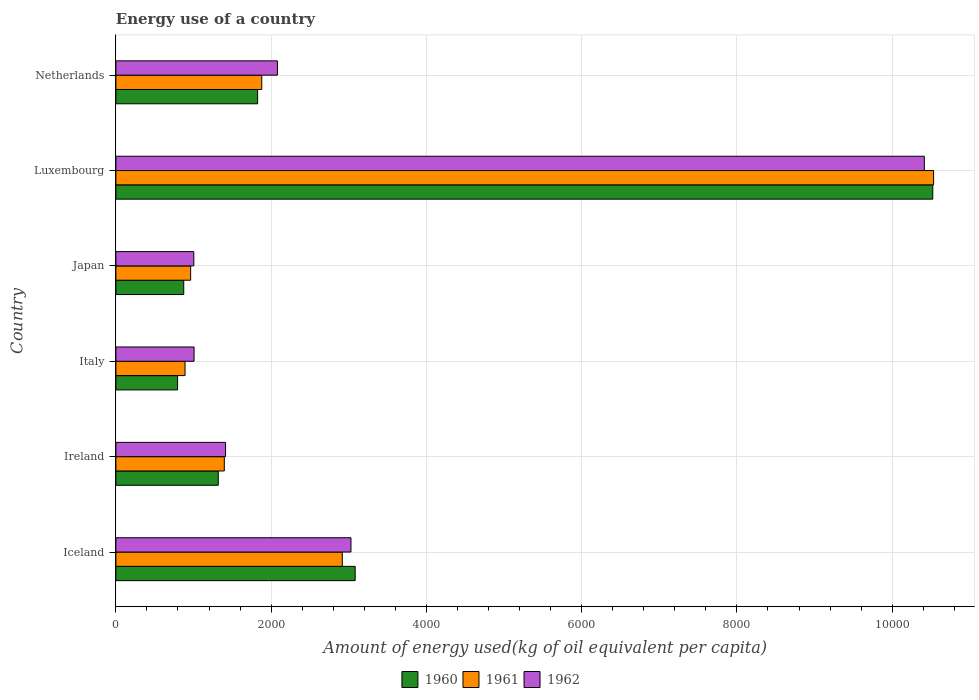How many groups of bars are there?
Provide a succinct answer. 6. Are the number of bars per tick equal to the number of legend labels?
Provide a succinct answer. Yes. How many bars are there on the 1st tick from the top?
Provide a short and direct response. 3. How many bars are there on the 2nd tick from the bottom?
Ensure brevity in your answer.  3. In how many cases, is the number of bars for a given country not equal to the number of legend labels?
Ensure brevity in your answer.  0. What is the amount of energy used in in 1961 in Ireland?
Provide a short and direct response. 1396.47. Across all countries, what is the maximum amount of energy used in in 1962?
Provide a short and direct response. 1.04e+04. Across all countries, what is the minimum amount of energy used in in 1960?
Your answer should be very brief. 794.82. In which country was the amount of energy used in in 1961 maximum?
Offer a very short reply. Luxembourg. What is the total amount of energy used in in 1960 in the graph?
Offer a terse response. 1.84e+04. What is the difference between the amount of energy used in in 1962 in Iceland and that in Italy?
Offer a very short reply. 2021.25. What is the difference between the amount of energy used in in 1961 in Japan and the amount of energy used in in 1962 in Ireland?
Ensure brevity in your answer.  -449.82. What is the average amount of energy used in in 1962 per country?
Offer a terse response. 3157.9. What is the difference between the amount of energy used in in 1962 and amount of energy used in in 1961 in Netherlands?
Give a very brief answer. 201.86. In how many countries, is the amount of energy used in in 1960 greater than 6000 kg?
Provide a short and direct response. 1. What is the ratio of the amount of energy used in in 1962 in Ireland to that in Netherlands?
Give a very brief answer. 0.68. Is the amount of energy used in in 1960 in Iceland less than that in Italy?
Your answer should be compact. No. What is the difference between the highest and the second highest amount of energy used in in 1961?
Your answer should be very brief. 7617.31. What is the difference between the highest and the lowest amount of energy used in in 1961?
Provide a succinct answer. 9643.33. In how many countries, is the amount of energy used in in 1960 greater than the average amount of energy used in in 1960 taken over all countries?
Give a very brief answer. 2. Is the sum of the amount of energy used in in 1960 in Ireland and Luxembourg greater than the maximum amount of energy used in in 1962 across all countries?
Make the answer very short. Yes. What does the 3rd bar from the top in Ireland represents?
Give a very brief answer. 1960. Is it the case that in every country, the sum of the amount of energy used in in 1962 and amount of energy used in in 1961 is greater than the amount of energy used in in 1960?
Provide a succinct answer. Yes. How many countries are there in the graph?
Provide a short and direct response. 6. How many legend labels are there?
Offer a very short reply. 3. What is the title of the graph?
Provide a succinct answer. Energy use of a country. What is the label or title of the X-axis?
Offer a very short reply. Amount of energy used(kg of oil equivalent per capita). What is the Amount of energy used(kg of oil equivalent per capita) of 1960 in Iceland?
Make the answer very short. 3082.71. What is the Amount of energy used(kg of oil equivalent per capita) of 1961 in Iceland?
Provide a short and direct response. 2916.71. What is the Amount of energy used(kg of oil equivalent per capita) in 1962 in Iceland?
Your response must be concise. 3028.3. What is the Amount of energy used(kg of oil equivalent per capita) in 1960 in Ireland?
Keep it short and to the point. 1318.81. What is the Amount of energy used(kg of oil equivalent per capita) in 1961 in Ireland?
Provide a succinct answer. 1396.47. What is the Amount of energy used(kg of oil equivalent per capita) of 1962 in Ireland?
Keep it short and to the point. 1412.73. What is the Amount of energy used(kg of oil equivalent per capita) of 1960 in Italy?
Your answer should be compact. 794.82. What is the Amount of energy used(kg of oil equivalent per capita) in 1961 in Italy?
Make the answer very short. 890.69. What is the Amount of energy used(kg of oil equivalent per capita) in 1962 in Italy?
Offer a very short reply. 1007.05. What is the Amount of energy used(kg of oil equivalent per capita) in 1960 in Japan?
Provide a succinct answer. 873.91. What is the Amount of energy used(kg of oil equivalent per capita) of 1961 in Japan?
Give a very brief answer. 962.91. What is the Amount of energy used(kg of oil equivalent per capita) of 1962 in Japan?
Keep it short and to the point. 1003.75. What is the Amount of energy used(kg of oil equivalent per capita) of 1960 in Luxembourg?
Ensure brevity in your answer.  1.05e+04. What is the Amount of energy used(kg of oil equivalent per capita) of 1961 in Luxembourg?
Provide a short and direct response. 1.05e+04. What is the Amount of energy used(kg of oil equivalent per capita) in 1962 in Luxembourg?
Make the answer very short. 1.04e+04. What is the Amount of energy used(kg of oil equivalent per capita) of 1960 in Netherlands?
Give a very brief answer. 1825.93. What is the Amount of energy used(kg of oil equivalent per capita) in 1961 in Netherlands?
Give a very brief answer. 1879.15. What is the Amount of energy used(kg of oil equivalent per capita) of 1962 in Netherlands?
Your answer should be compact. 2081.01. Across all countries, what is the maximum Amount of energy used(kg of oil equivalent per capita) of 1960?
Offer a very short reply. 1.05e+04. Across all countries, what is the maximum Amount of energy used(kg of oil equivalent per capita) in 1961?
Give a very brief answer. 1.05e+04. Across all countries, what is the maximum Amount of energy used(kg of oil equivalent per capita) of 1962?
Ensure brevity in your answer.  1.04e+04. Across all countries, what is the minimum Amount of energy used(kg of oil equivalent per capita) of 1960?
Provide a short and direct response. 794.82. Across all countries, what is the minimum Amount of energy used(kg of oil equivalent per capita) in 1961?
Your answer should be very brief. 890.69. Across all countries, what is the minimum Amount of energy used(kg of oil equivalent per capita) of 1962?
Give a very brief answer. 1003.75. What is the total Amount of energy used(kg of oil equivalent per capita) in 1960 in the graph?
Your answer should be compact. 1.84e+04. What is the total Amount of energy used(kg of oil equivalent per capita) in 1961 in the graph?
Give a very brief answer. 1.86e+04. What is the total Amount of energy used(kg of oil equivalent per capita) of 1962 in the graph?
Your answer should be very brief. 1.89e+04. What is the difference between the Amount of energy used(kg of oil equivalent per capita) in 1960 in Iceland and that in Ireland?
Make the answer very short. 1763.9. What is the difference between the Amount of energy used(kg of oil equivalent per capita) in 1961 in Iceland and that in Ireland?
Your answer should be very brief. 1520.24. What is the difference between the Amount of energy used(kg of oil equivalent per capita) of 1962 in Iceland and that in Ireland?
Your response must be concise. 1615.57. What is the difference between the Amount of energy used(kg of oil equivalent per capita) in 1960 in Iceland and that in Italy?
Your answer should be very brief. 2287.9. What is the difference between the Amount of energy used(kg of oil equivalent per capita) of 1961 in Iceland and that in Italy?
Offer a very short reply. 2026.02. What is the difference between the Amount of energy used(kg of oil equivalent per capita) of 1962 in Iceland and that in Italy?
Your answer should be very brief. 2021.25. What is the difference between the Amount of energy used(kg of oil equivalent per capita) in 1960 in Iceland and that in Japan?
Offer a very short reply. 2208.8. What is the difference between the Amount of energy used(kg of oil equivalent per capita) in 1961 in Iceland and that in Japan?
Your answer should be very brief. 1953.8. What is the difference between the Amount of energy used(kg of oil equivalent per capita) in 1962 in Iceland and that in Japan?
Ensure brevity in your answer.  2024.55. What is the difference between the Amount of energy used(kg of oil equivalent per capita) in 1960 in Iceland and that in Luxembourg?
Offer a very short reply. -7440.7. What is the difference between the Amount of energy used(kg of oil equivalent per capita) in 1961 in Iceland and that in Luxembourg?
Offer a terse response. -7617.31. What is the difference between the Amount of energy used(kg of oil equivalent per capita) in 1962 in Iceland and that in Luxembourg?
Provide a short and direct response. -7386.24. What is the difference between the Amount of energy used(kg of oil equivalent per capita) in 1960 in Iceland and that in Netherlands?
Offer a terse response. 1256.78. What is the difference between the Amount of energy used(kg of oil equivalent per capita) in 1961 in Iceland and that in Netherlands?
Your answer should be very brief. 1037.56. What is the difference between the Amount of energy used(kg of oil equivalent per capita) of 1962 in Iceland and that in Netherlands?
Keep it short and to the point. 947.29. What is the difference between the Amount of energy used(kg of oil equivalent per capita) in 1960 in Ireland and that in Italy?
Your answer should be compact. 524. What is the difference between the Amount of energy used(kg of oil equivalent per capita) of 1961 in Ireland and that in Italy?
Offer a terse response. 505.78. What is the difference between the Amount of energy used(kg of oil equivalent per capita) in 1962 in Ireland and that in Italy?
Give a very brief answer. 405.68. What is the difference between the Amount of energy used(kg of oil equivalent per capita) in 1960 in Ireland and that in Japan?
Your answer should be compact. 444.9. What is the difference between the Amount of energy used(kg of oil equivalent per capita) of 1961 in Ireland and that in Japan?
Your response must be concise. 433.56. What is the difference between the Amount of energy used(kg of oil equivalent per capita) of 1962 in Ireland and that in Japan?
Your answer should be compact. 408.98. What is the difference between the Amount of energy used(kg of oil equivalent per capita) of 1960 in Ireland and that in Luxembourg?
Your response must be concise. -9204.59. What is the difference between the Amount of energy used(kg of oil equivalent per capita) in 1961 in Ireland and that in Luxembourg?
Give a very brief answer. -9137.55. What is the difference between the Amount of energy used(kg of oil equivalent per capita) in 1962 in Ireland and that in Luxembourg?
Keep it short and to the point. -9001.81. What is the difference between the Amount of energy used(kg of oil equivalent per capita) of 1960 in Ireland and that in Netherlands?
Your answer should be very brief. -507.12. What is the difference between the Amount of energy used(kg of oil equivalent per capita) in 1961 in Ireland and that in Netherlands?
Give a very brief answer. -482.68. What is the difference between the Amount of energy used(kg of oil equivalent per capita) in 1962 in Ireland and that in Netherlands?
Your response must be concise. -668.28. What is the difference between the Amount of energy used(kg of oil equivalent per capita) in 1960 in Italy and that in Japan?
Provide a succinct answer. -79.09. What is the difference between the Amount of energy used(kg of oil equivalent per capita) in 1961 in Italy and that in Japan?
Your answer should be very brief. -72.22. What is the difference between the Amount of energy used(kg of oil equivalent per capita) of 1962 in Italy and that in Japan?
Your answer should be compact. 3.3. What is the difference between the Amount of energy used(kg of oil equivalent per capita) in 1960 in Italy and that in Luxembourg?
Your answer should be very brief. -9728.59. What is the difference between the Amount of energy used(kg of oil equivalent per capita) in 1961 in Italy and that in Luxembourg?
Provide a short and direct response. -9643.33. What is the difference between the Amount of energy used(kg of oil equivalent per capita) of 1962 in Italy and that in Luxembourg?
Provide a short and direct response. -9407.49. What is the difference between the Amount of energy used(kg of oil equivalent per capita) of 1960 in Italy and that in Netherlands?
Your response must be concise. -1031.12. What is the difference between the Amount of energy used(kg of oil equivalent per capita) of 1961 in Italy and that in Netherlands?
Give a very brief answer. -988.46. What is the difference between the Amount of energy used(kg of oil equivalent per capita) of 1962 in Italy and that in Netherlands?
Give a very brief answer. -1073.96. What is the difference between the Amount of energy used(kg of oil equivalent per capita) of 1960 in Japan and that in Luxembourg?
Make the answer very short. -9649.5. What is the difference between the Amount of energy used(kg of oil equivalent per capita) in 1961 in Japan and that in Luxembourg?
Offer a terse response. -9571.11. What is the difference between the Amount of energy used(kg of oil equivalent per capita) in 1962 in Japan and that in Luxembourg?
Keep it short and to the point. -9410.79. What is the difference between the Amount of energy used(kg of oil equivalent per capita) in 1960 in Japan and that in Netherlands?
Your answer should be very brief. -952.02. What is the difference between the Amount of energy used(kg of oil equivalent per capita) of 1961 in Japan and that in Netherlands?
Provide a short and direct response. -916.24. What is the difference between the Amount of energy used(kg of oil equivalent per capita) in 1962 in Japan and that in Netherlands?
Provide a short and direct response. -1077.26. What is the difference between the Amount of energy used(kg of oil equivalent per capita) of 1960 in Luxembourg and that in Netherlands?
Keep it short and to the point. 8697.47. What is the difference between the Amount of energy used(kg of oil equivalent per capita) of 1961 in Luxembourg and that in Netherlands?
Offer a very short reply. 8654.87. What is the difference between the Amount of energy used(kg of oil equivalent per capita) in 1962 in Luxembourg and that in Netherlands?
Offer a terse response. 8333.53. What is the difference between the Amount of energy used(kg of oil equivalent per capita) of 1960 in Iceland and the Amount of energy used(kg of oil equivalent per capita) of 1961 in Ireland?
Give a very brief answer. 1686.25. What is the difference between the Amount of energy used(kg of oil equivalent per capita) of 1960 in Iceland and the Amount of energy used(kg of oil equivalent per capita) of 1962 in Ireland?
Make the answer very short. 1669.98. What is the difference between the Amount of energy used(kg of oil equivalent per capita) in 1961 in Iceland and the Amount of energy used(kg of oil equivalent per capita) in 1962 in Ireland?
Provide a short and direct response. 1503.98. What is the difference between the Amount of energy used(kg of oil equivalent per capita) in 1960 in Iceland and the Amount of energy used(kg of oil equivalent per capita) in 1961 in Italy?
Offer a very short reply. 2192.02. What is the difference between the Amount of energy used(kg of oil equivalent per capita) in 1960 in Iceland and the Amount of energy used(kg of oil equivalent per capita) in 1962 in Italy?
Ensure brevity in your answer.  2075.66. What is the difference between the Amount of energy used(kg of oil equivalent per capita) in 1961 in Iceland and the Amount of energy used(kg of oil equivalent per capita) in 1962 in Italy?
Your answer should be compact. 1909.66. What is the difference between the Amount of energy used(kg of oil equivalent per capita) in 1960 in Iceland and the Amount of energy used(kg of oil equivalent per capita) in 1961 in Japan?
Ensure brevity in your answer.  2119.8. What is the difference between the Amount of energy used(kg of oil equivalent per capita) in 1960 in Iceland and the Amount of energy used(kg of oil equivalent per capita) in 1962 in Japan?
Your answer should be compact. 2078.96. What is the difference between the Amount of energy used(kg of oil equivalent per capita) in 1961 in Iceland and the Amount of energy used(kg of oil equivalent per capita) in 1962 in Japan?
Ensure brevity in your answer.  1912.95. What is the difference between the Amount of energy used(kg of oil equivalent per capita) in 1960 in Iceland and the Amount of energy used(kg of oil equivalent per capita) in 1961 in Luxembourg?
Offer a terse response. -7451.31. What is the difference between the Amount of energy used(kg of oil equivalent per capita) in 1960 in Iceland and the Amount of energy used(kg of oil equivalent per capita) in 1962 in Luxembourg?
Offer a terse response. -7331.83. What is the difference between the Amount of energy used(kg of oil equivalent per capita) in 1961 in Iceland and the Amount of energy used(kg of oil equivalent per capita) in 1962 in Luxembourg?
Your response must be concise. -7497.83. What is the difference between the Amount of energy used(kg of oil equivalent per capita) in 1960 in Iceland and the Amount of energy used(kg of oil equivalent per capita) in 1961 in Netherlands?
Your answer should be compact. 1203.56. What is the difference between the Amount of energy used(kg of oil equivalent per capita) in 1960 in Iceland and the Amount of energy used(kg of oil equivalent per capita) in 1962 in Netherlands?
Provide a short and direct response. 1001.7. What is the difference between the Amount of energy used(kg of oil equivalent per capita) of 1961 in Iceland and the Amount of energy used(kg of oil equivalent per capita) of 1962 in Netherlands?
Provide a short and direct response. 835.69. What is the difference between the Amount of energy used(kg of oil equivalent per capita) of 1960 in Ireland and the Amount of energy used(kg of oil equivalent per capita) of 1961 in Italy?
Your answer should be compact. 428.12. What is the difference between the Amount of energy used(kg of oil equivalent per capita) in 1960 in Ireland and the Amount of energy used(kg of oil equivalent per capita) in 1962 in Italy?
Provide a succinct answer. 311.76. What is the difference between the Amount of energy used(kg of oil equivalent per capita) of 1961 in Ireland and the Amount of energy used(kg of oil equivalent per capita) of 1962 in Italy?
Ensure brevity in your answer.  389.42. What is the difference between the Amount of energy used(kg of oil equivalent per capita) in 1960 in Ireland and the Amount of energy used(kg of oil equivalent per capita) in 1961 in Japan?
Offer a very short reply. 355.91. What is the difference between the Amount of energy used(kg of oil equivalent per capita) in 1960 in Ireland and the Amount of energy used(kg of oil equivalent per capita) in 1962 in Japan?
Offer a terse response. 315.06. What is the difference between the Amount of energy used(kg of oil equivalent per capita) in 1961 in Ireland and the Amount of energy used(kg of oil equivalent per capita) in 1962 in Japan?
Give a very brief answer. 392.71. What is the difference between the Amount of energy used(kg of oil equivalent per capita) of 1960 in Ireland and the Amount of energy used(kg of oil equivalent per capita) of 1961 in Luxembourg?
Make the answer very short. -9215.21. What is the difference between the Amount of energy used(kg of oil equivalent per capita) in 1960 in Ireland and the Amount of energy used(kg of oil equivalent per capita) in 1962 in Luxembourg?
Make the answer very short. -9095.73. What is the difference between the Amount of energy used(kg of oil equivalent per capita) in 1961 in Ireland and the Amount of energy used(kg of oil equivalent per capita) in 1962 in Luxembourg?
Ensure brevity in your answer.  -9018.07. What is the difference between the Amount of energy used(kg of oil equivalent per capita) of 1960 in Ireland and the Amount of energy used(kg of oil equivalent per capita) of 1961 in Netherlands?
Ensure brevity in your answer.  -560.34. What is the difference between the Amount of energy used(kg of oil equivalent per capita) in 1960 in Ireland and the Amount of energy used(kg of oil equivalent per capita) in 1962 in Netherlands?
Your answer should be compact. -762.2. What is the difference between the Amount of energy used(kg of oil equivalent per capita) in 1961 in Ireland and the Amount of energy used(kg of oil equivalent per capita) in 1962 in Netherlands?
Give a very brief answer. -684.55. What is the difference between the Amount of energy used(kg of oil equivalent per capita) in 1960 in Italy and the Amount of energy used(kg of oil equivalent per capita) in 1961 in Japan?
Give a very brief answer. -168.09. What is the difference between the Amount of energy used(kg of oil equivalent per capita) of 1960 in Italy and the Amount of energy used(kg of oil equivalent per capita) of 1962 in Japan?
Offer a very short reply. -208.94. What is the difference between the Amount of energy used(kg of oil equivalent per capita) in 1961 in Italy and the Amount of energy used(kg of oil equivalent per capita) in 1962 in Japan?
Provide a short and direct response. -113.06. What is the difference between the Amount of energy used(kg of oil equivalent per capita) of 1960 in Italy and the Amount of energy used(kg of oil equivalent per capita) of 1961 in Luxembourg?
Give a very brief answer. -9739.2. What is the difference between the Amount of energy used(kg of oil equivalent per capita) of 1960 in Italy and the Amount of energy used(kg of oil equivalent per capita) of 1962 in Luxembourg?
Offer a terse response. -9619.72. What is the difference between the Amount of energy used(kg of oil equivalent per capita) in 1961 in Italy and the Amount of energy used(kg of oil equivalent per capita) in 1962 in Luxembourg?
Give a very brief answer. -9523.85. What is the difference between the Amount of energy used(kg of oil equivalent per capita) in 1960 in Italy and the Amount of energy used(kg of oil equivalent per capita) in 1961 in Netherlands?
Make the answer very short. -1084.33. What is the difference between the Amount of energy used(kg of oil equivalent per capita) of 1960 in Italy and the Amount of energy used(kg of oil equivalent per capita) of 1962 in Netherlands?
Provide a succinct answer. -1286.2. What is the difference between the Amount of energy used(kg of oil equivalent per capita) of 1961 in Italy and the Amount of energy used(kg of oil equivalent per capita) of 1962 in Netherlands?
Keep it short and to the point. -1190.32. What is the difference between the Amount of energy used(kg of oil equivalent per capita) of 1960 in Japan and the Amount of energy used(kg of oil equivalent per capita) of 1961 in Luxembourg?
Provide a succinct answer. -9660.11. What is the difference between the Amount of energy used(kg of oil equivalent per capita) in 1960 in Japan and the Amount of energy used(kg of oil equivalent per capita) in 1962 in Luxembourg?
Ensure brevity in your answer.  -9540.63. What is the difference between the Amount of energy used(kg of oil equivalent per capita) in 1961 in Japan and the Amount of energy used(kg of oil equivalent per capita) in 1962 in Luxembourg?
Ensure brevity in your answer.  -9451.63. What is the difference between the Amount of energy used(kg of oil equivalent per capita) in 1960 in Japan and the Amount of energy used(kg of oil equivalent per capita) in 1961 in Netherlands?
Your answer should be very brief. -1005.24. What is the difference between the Amount of energy used(kg of oil equivalent per capita) in 1960 in Japan and the Amount of energy used(kg of oil equivalent per capita) in 1962 in Netherlands?
Your answer should be compact. -1207.1. What is the difference between the Amount of energy used(kg of oil equivalent per capita) in 1961 in Japan and the Amount of energy used(kg of oil equivalent per capita) in 1962 in Netherlands?
Ensure brevity in your answer.  -1118.1. What is the difference between the Amount of energy used(kg of oil equivalent per capita) in 1960 in Luxembourg and the Amount of energy used(kg of oil equivalent per capita) in 1961 in Netherlands?
Provide a short and direct response. 8644.26. What is the difference between the Amount of energy used(kg of oil equivalent per capita) of 1960 in Luxembourg and the Amount of energy used(kg of oil equivalent per capita) of 1962 in Netherlands?
Provide a short and direct response. 8442.4. What is the difference between the Amount of energy used(kg of oil equivalent per capita) of 1961 in Luxembourg and the Amount of energy used(kg of oil equivalent per capita) of 1962 in Netherlands?
Make the answer very short. 8453.01. What is the average Amount of energy used(kg of oil equivalent per capita) of 1960 per country?
Provide a short and direct response. 3069.93. What is the average Amount of energy used(kg of oil equivalent per capita) of 1961 per country?
Give a very brief answer. 3096.66. What is the average Amount of energy used(kg of oil equivalent per capita) of 1962 per country?
Your response must be concise. 3157.9. What is the difference between the Amount of energy used(kg of oil equivalent per capita) of 1960 and Amount of energy used(kg of oil equivalent per capita) of 1961 in Iceland?
Your response must be concise. 166.01. What is the difference between the Amount of energy used(kg of oil equivalent per capita) of 1960 and Amount of energy used(kg of oil equivalent per capita) of 1962 in Iceland?
Your response must be concise. 54.41. What is the difference between the Amount of energy used(kg of oil equivalent per capita) of 1961 and Amount of energy used(kg of oil equivalent per capita) of 1962 in Iceland?
Offer a very short reply. -111.59. What is the difference between the Amount of energy used(kg of oil equivalent per capita) of 1960 and Amount of energy used(kg of oil equivalent per capita) of 1961 in Ireland?
Offer a very short reply. -77.65. What is the difference between the Amount of energy used(kg of oil equivalent per capita) of 1960 and Amount of energy used(kg of oil equivalent per capita) of 1962 in Ireland?
Make the answer very short. -93.92. What is the difference between the Amount of energy used(kg of oil equivalent per capita) in 1961 and Amount of energy used(kg of oil equivalent per capita) in 1962 in Ireland?
Provide a succinct answer. -16.26. What is the difference between the Amount of energy used(kg of oil equivalent per capita) of 1960 and Amount of energy used(kg of oil equivalent per capita) of 1961 in Italy?
Your response must be concise. -95.87. What is the difference between the Amount of energy used(kg of oil equivalent per capita) of 1960 and Amount of energy used(kg of oil equivalent per capita) of 1962 in Italy?
Offer a very short reply. -212.23. What is the difference between the Amount of energy used(kg of oil equivalent per capita) in 1961 and Amount of energy used(kg of oil equivalent per capita) in 1962 in Italy?
Give a very brief answer. -116.36. What is the difference between the Amount of energy used(kg of oil equivalent per capita) of 1960 and Amount of energy used(kg of oil equivalent per capita) of 1961 in Japan?
Give a very brief answer. -89. What is the difference between the Amount of energy used(kg of oil equivalent per capita) in 1960 and Amount of energy used(kg of oil equivalent per capita) in 1962 in Japan?
Your answer should be very brief. -129.84. What is the difference between the Amount of energy used(kg of oil equivalent per capita) in 1961 and Amount of energy used(kg of oil equivalent per capita) in 1962 in Japan?
Make the answer very short. -40.85. What is the difference between the Amount of energy used(kg of oil equivalent per capita) of 1960 and Amount of energy used(kg of oil equivalent per capita) of 1961 in Luxembourg?
Your answer should be very brief. -10.61. What is the difference between the Amount of energy used(kg of oil equivalent per capita) of 1960 and Amount of energy used(kg of oil equivalent per capita) of 1962 in Luxembourg?
Give a very brief answer. 108.87. What is the difference between the Amount of energy used(kg of oil equivalent per capita) of 1961 and Amount of energy used(kg of oil equivalent per capita) of 1962 in Luxembourg?
Make the answer very short. 119.48. What is the difference between the Amount of energy used(kg of oil equivalent per capita) of 1960 and Amount of energy used(kg of oil equivalent per capita) of 1961 in Netherlands?
Provide a short and direct response. -53.22. What is the difference between the Amount of energy used(kg of oil equivalent per capita) in 1960 and Amount of energy used(kg of oil equivalent per capita) in 1962 in Netherlands?
Make the answer very short. -255.08. What is the difference between the Amount of energy used(kg of oil equivalent per capita) in 1961 and Amount of energy used(kg of oil equivalent per capita) in 1962 in Netherlands?
Give a very brief answer. -201.86. What is the ratio of the Amount of energy used(kg of oil equivalent per capita) of 1960 in Iceland to that in Ireland?
Keep it short and to the point. 2.34. What is the ratio of the Amount of energy used(kg of oil equivalent per capita) in 1961 in Iceland to that in Ireland?
Offer a terse response. 2.09. What is the ratio of the Amount of energy used(kg of oil equivalent per capita) in 1962 in Iceland to that in Ireland?
Your answer should be compact. 2.14. What is the ratio of the Amount of energy used(kg of oil equivalent per capita) of 1960 in Iceland to that in Italy?
Ensure brevity in your answer.  3.88. What is the ratio of the Amount of energy used(kg of oil equivalent per capita) in 1961 in Iceland to that in Italy?
Make the answer very short. 3.27. What is the ratio of the Amount of energy used(kg of oil equivalent per capita) in 1962 in Iceland to that in Italy?
Ensure brevity in your answer.  3.01. What is the ratio of the Amount of energy used(kg of oil equivalent per capita) in 1960 in Iceland to that in Japan?
Make the answer very short. 3.53. What is the ratio of the Amount of energy used(kg of oil equivalent per capita) in 1961 in Iceland to that in Japan?
Give a very brief answer. 3.03. What is the ratio of the Amount of energy used(kg of oil equivalent per capita) in 1962 in Iceland to that in Japan?
Offer a terse response. 3.02. What is the ratio of the Amount of energy used(kg of oil equivalent per capita) of 1960 in Iceland to that in Luxembourg?
Offer a very short reply. 0.29. What is the ratio of the Amount of energy used(kg of oil equivalent per capita) of 1961 in Iceland to that in Luxembourg?
Your answer should be very brief. 0.28. What is the ratio of the Amount of energy used(kg of oil equivalent per capita) in 1962 in Iceland to that in Luxembourg?
Offer a very short reply. 0.29. What is the ratio of the Amount of energy used(kg of oil equivalent per capita) in 1960 in Iceland to that in Netherlands?
Your answer should be very brief. 1.69. What is the ratio of the Amount of energy used(kg of oil equivalent per capita) in 1961 in Iceland to that in Netherlands?
Offer a terse response. 1.55. What is the ratio of the Amount of energy used(kg of oil equivalent per capita) in 1962 in Iceland to that in Netherlands?
Your response must be concise. 1.46. What is the ratio of the Amount of energy used(kg of oil equivalent per capita) of 1960 in Ireland to that in Italy?
Your response must be concise. 1.66. What is the ratio of the Amount of energy used(kg of oil equivalent per capita) in 1961 in Ireland to that in Italy?
Your answer should be very brief. 1.57. What is the ratio of the Amount of energy used(kg of oil equivalent per capita) of 1962 in Ireland to that in Italy?
Provide a succinct answer. 1.4. What is the ratio of the Amount of energy used(kg of oil equivalent per capita) of 1960 in Ireland to that in Japan?
Offer a terse response. 1.51. What is the ratio of the Amount of energy used(kg of oil equivalent per capita) of 1961 in Ireland to that in Japan?
Give a very brief answer. 1.45. What is the ratio of the Amount of energy used(kg of oil equivalent per capita) of 1962 in Ireland to that in Japan?
Provide a short and direct response. 1.41. What is the ratio of the Amount of energy used(kg of oil equivalent per capita) in 1960 in Ireland to that in Luxembourg?
Provide a succinct answer. 0.13. What is the ratio of the Amount of energy used(kg of oil equivalent per capita) of 1961 in Ireland to that in Luxembourg?
Provide a short and direct response. 0.13. What is the ratio of the Amount of energy used(kg of oil equivalent per capita) in 1962 in Ireland to that in Luxembourg?
Your response must be concise. 0.14. What is the ratio of the Amount of energy used(kg of oil equivalent per capita) in 1960 in Ireland to that in Netherlands?
Keep it short and to the point. 0.72. What is the ratio of the Amount of energy used(kg of oil equivalent per capita) in 1961 in Ireland to that in Netherlands?
Make the answer very short. 0.74. What is the ratio of the Amount of energy used(kg of oil equivalent per capita) in 1962 in Ireland to that in Netherlands?
Your answer should be compact. 0.68. What is the ratio of the Amount of energy used(kg of oil equivalent per capita) of 1960 in Italy to that in Japan?
Offer a very short reply. 0.91. What is the ratio of the Amount of energy used(kg of oil equivalent per capita) in 1961 in Italy to that in Japan?
Your answer should be very brief. 0.93. What is the ratio of the Amount of energy used(kg of oil equivalent per capita) in 1960 in Italy to that in Luxembourg?
Give a very brief answer. 0.08. What is the ratio of the Amount of energy used(kg of oil equivalent per capita) in 1961 in Italy to that in Luxembourg?
Give a very brief answer. 0.08. What is the ratio of the Amount of energy used(kg of oil equivalent per capita) of 1962 in Italy to that in Luxembourg?
Your response must be concise. 0.1. What is the ratio of the Amount of energy used(kg of oil equivalent per capita) in 1960 in Italy to that in Netherlands?
Provide a short and direct response. 0.44. What is the ratio of the Amount of energy used(kg of oil equivalent per capita) of 1961 in Italy to that in Netherlands?
Provide a succinct answer. 0.47. What is the ratio of the Amount of energy used(kg of oil equivalent per capita) of 1962 in Italy to that in Netherlands?
Provide a succinct answer. 0.48. What is the ratio of the Amount of energy used(kg of oil equivalent per capita) of 1960 in Japan to that in Luxembourg?
Provide a short and direct response. 0.08. What is the ratio of the Amount of energy used(kg of oil equivalent per capita) in 1961 in Japan to that in Luxembourg?
Your answer should be very brief. 0.09. What is the ratio of the Amount of energy used(kg of oil equivalent per capita) of 1962 in Japan to that in Luxembourg?
Give a very brief answer. 0.1. What is the ratio of the Amount of energy used(kg of oil equivalent per capita) of 1960 in Japan to that in Netherlands?
Keep it short and to the point. 0.48. What is the ratio of the Amount of energy used(kg of oil equivalent per capita) in 1961 in Japan to that in Netherlands?
Give a very brief answer. 0.51. What is the ratio of the Amount of energy used(kg of oil equivalent per capita) in 1962 in Japan to that in Netherlands?
Your answer should be compact. 0.48. What is the ratio of the Amount of energy used(kg of oil equivalent per capita) of 1960 in Luxembourg to that in Netherlands?
Provide a short and direct response. 5.76. What is the ratio of the Amount of energy used(kg of oil equivalent per capita) in 1961 in Luxembourg to that in Netherlands?
Ensure brevity in your answer.  5.61. What is the ratio of the Amount of energy used(kg of oil equivalent per capita) of 1962 in Luxembourg to that in Netherlands?
Provide a short and direct response. 5. What is the difference between the highest and the second highest Amount of energy used(kg of oil equivalent per capita) of 1960?
Provide a short and direct response. 7440.7. What is the difference between the highest and the second highest Amount of energy used(kg of oil equivalent per capita) of 1961?
Offer a very short reply. 7617.31. What is the difference between the highest and the second highest Amount of energy used(kg of oil equivalent per capita) of 1962?
Your answer should be very brief. 7386.24. What is the difference between the highest and the lowest Amount of energy used(kg of oil equivalent per capita) of 1960?
Offer a very short reply. 9728.59. What is the difference between the highest and the lowest Amount of energy used(kg of oil equivalent per capita) of 1961?
Your answer should be compact. 9643.33. What is the difference between the highest and the lowest Amount of energy used(kg of oil equivalent per capita) of 1962?
Your response must be concise. 9410.79. 